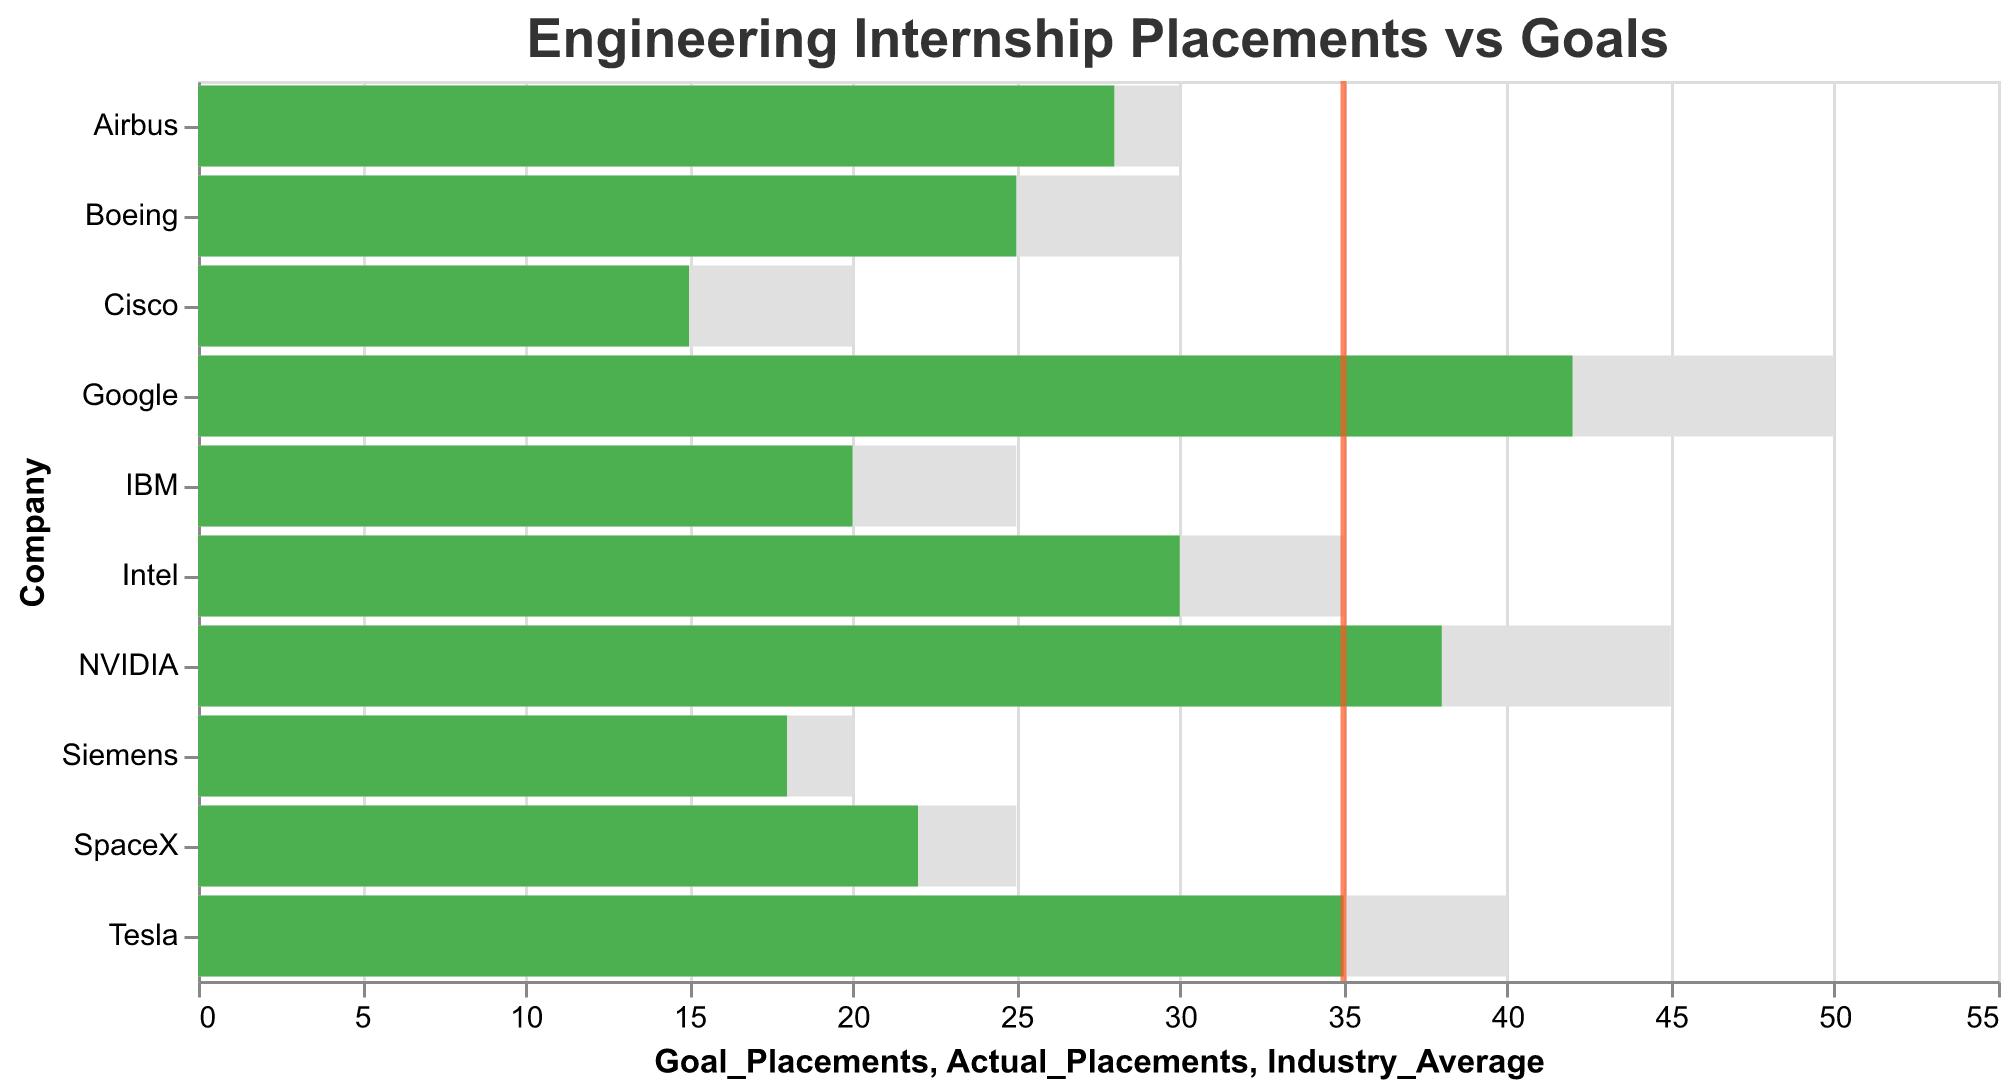What's the title of the figure? The title is located at the top of the chart and reads "Engineering Internship Placements vs Goals".
Answer: Engineering Internship Placements vs Goals What is the actual number of placements at Tesla? Look at the green bar corresponding to Tesla, which reaches the value of 35 on the x-axis.
Answer: 35 How many companies have an industry average indicated? Count the red ticks on the x-axis, one for each company. There are 10 red ticks.
Answer: 10 Which company had the highest goal placements? Compare the lengths of the light grey bars representing goal placements. Google has the longest bar, reaching 50.
Answer: Google What is the difference between the goal and actual placements for Boeing? For Boeing, the light grey bar (goal) is 30 and the green bar (actual) is 25. Subtract actual from goal: 30 - 25 = 5.
Answer: 5 Which company exceeded its goal placements by the largest margin? Subtract the length of the green bar (actual) from the light grey bar (goal) for all companies. Google has the largest margin of 50 - 42 = 8.
Answer: Google How does Intel's actual placements compare to the industry average? Look at Intel's green bar, which represents actual placements at 30, and compare it to the red tick at 35. Intel's actual placements are 5 less than the industry average.
Answer: 5 less What is the average goal placements across all companies? Sum up the goal placements (50 + 45 + 40 + 35 + 30 + 30 + 25 + 25 + 20 + 20) and divide by the number of companies (10). The sum is 320, and 320/10 = 32.
Answer: 32 Which companies did not meet their goal placements? Identify green bars that are shorter than their corresponding light grey bars. Companies include NVIDIA, Tesla, Intel, Airbus, Boeing, SpaceX, IBM, Siemens, and Cisco.
Answer: NVIDIA, Tesla, Intel, Airbus, Boeing, SpaceX, IBM, Siemens, Cisco What is the total number of actual placements across all companies? Sum up the actual placements (42 + 38 + 35 + 30 + 28 + 25 + 22 + 20 + 18 + 15) which totals to 273.
Answer: 273 